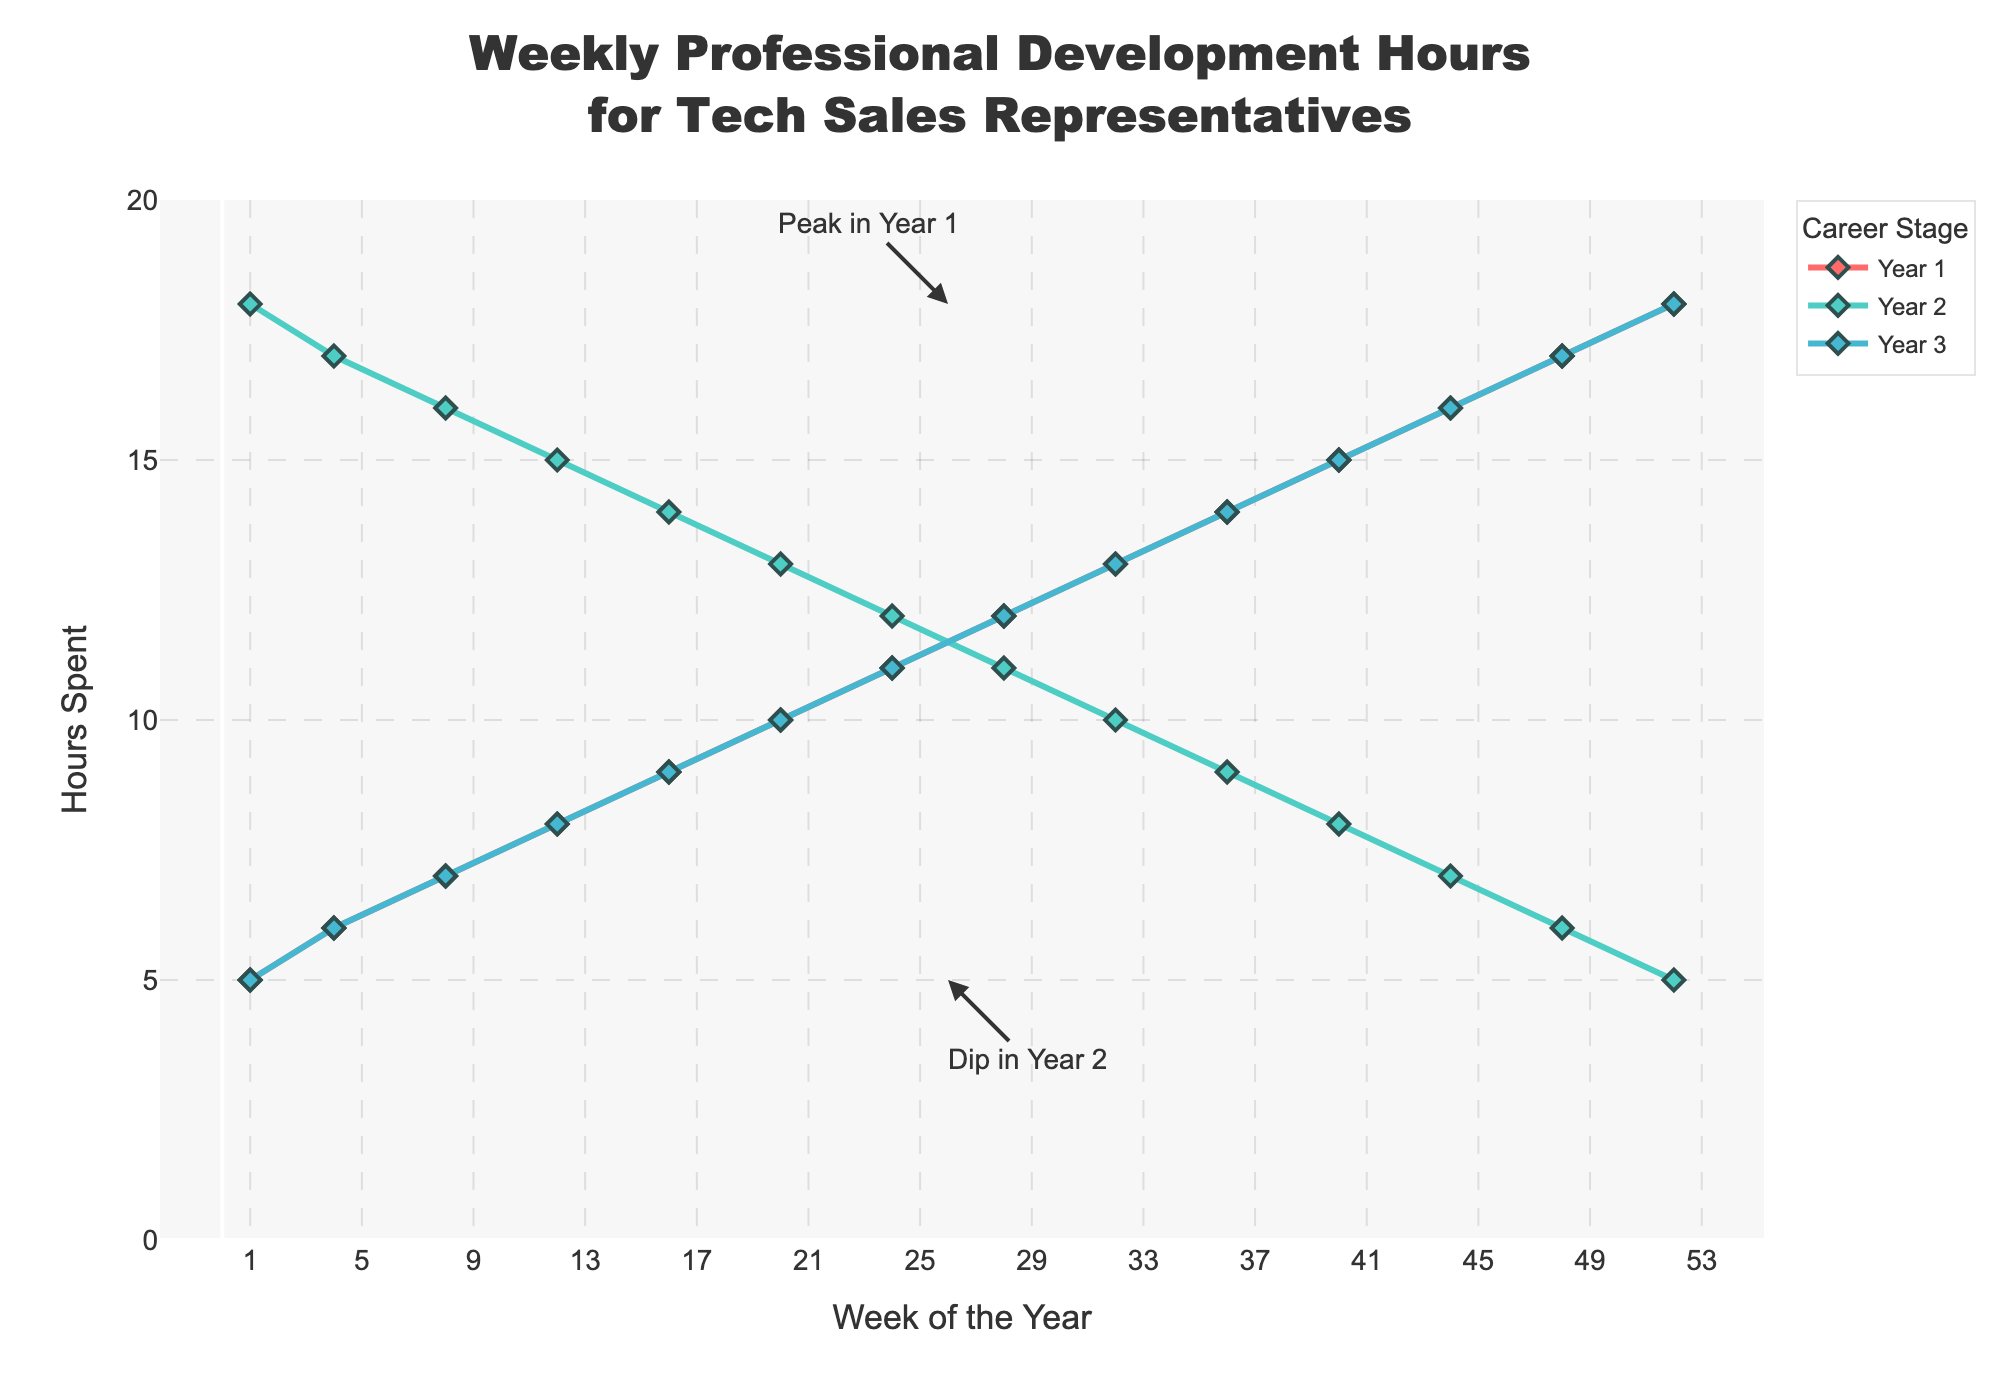How does the weekly professional development time change during Year 1? In Year 1, the time spent on professional development starts at 5 hours in the first week and steadily increases, reaching 18 hours by week 52.
Answer: Steadily increases What is the overall trend in Year 2 compared to Year 1? In Year 2, the weekly hours decrease progressively from 18 hours in the first week to 5 hours by week 52, which is the opposite trend compared to Year 1, where the hours continuously increased.
Answer: Decreasing During which year is the lowest weekly time spent on professional development observed? The lowest weekly time observed is 5 hours, which occurs in Year 3 during the first and last weeks.
Answer: Year 3 What's the difference in professional development hours between Week 24 and Week 28 in Year 3? In Year 3, Week 24 has 11 hours and Week 28 has 12 hours. The difference is 12 - 11 = 1 hour.
Answer: 1 hour Which year shows a repeating pattern of professional development hours, and what is that pattern? Year 3 shows a repeating pattern similar to Year 1, where the hours start at 5 in the first week and increase to 18 by the last week.
Answer: Year 3 How many weeks into Year 1 does it take for the professional development hours to reach 10 hours? In Year 1, professional development hours reach 10 hours in Week 20.
Answer: 20 weeks Could you identify a significant annotation on the chart? Yes, there is an annotation indicating a peak in Year 1 at Week 26 where the hours spent are 18.
Answer: Peak in Year 1 Compare the professional development hours in Week 16 of Year 2 and Week 16 of Year 3. In Week 16, Year 2 has 14 hours, while Year 3 has 9 hours. Year 2 has more hours.
Answer: Year 2 What's the visual effect of Year 2's trend on the chart? Year 2's decreasing trend contrasts with Year 1 and Year 3's increasing trends, visually distinguished through different colored lines and the downward direction of the line.
Answer: Downward trend Calculate the average weekly professional development hours for Year 3. To calculate: (5+6+...+18)/13 = 253/13 ≈ 14.53 hours.
Answer: 14.53 hours 